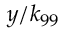<formula> <loc_0><loc_0><loc_500><loc_500>y / k _ { 9 9 }</formula> 